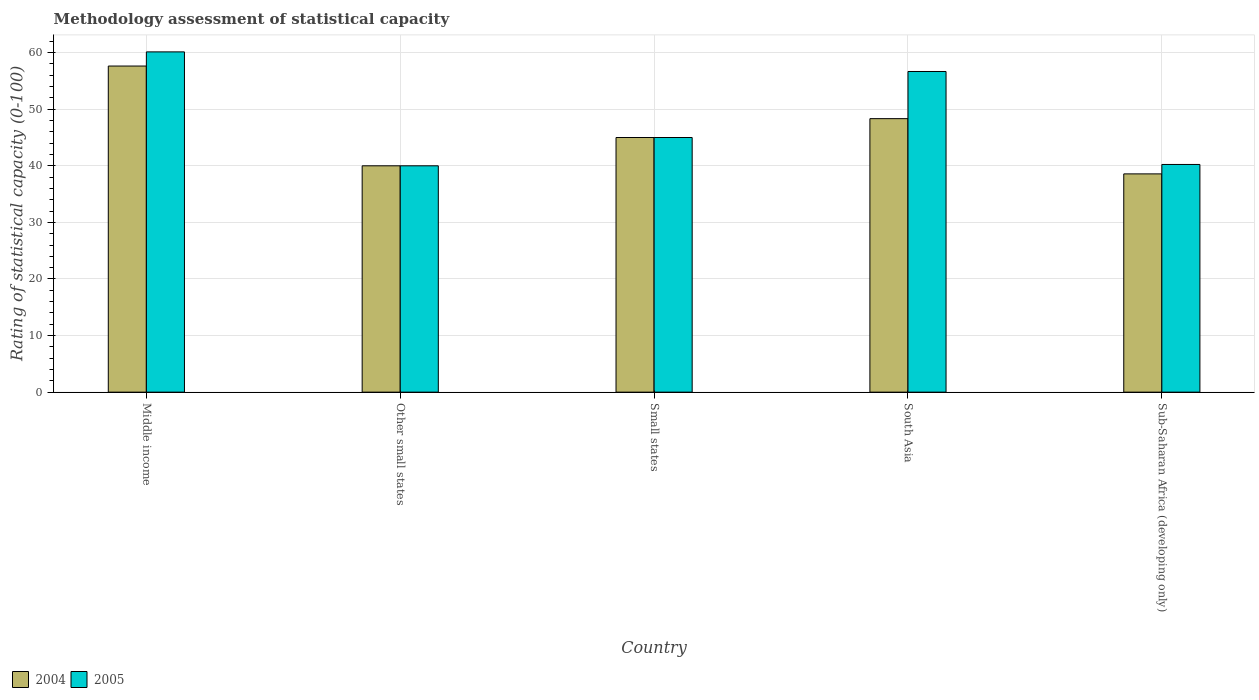How many different coloured bars are there?
Offer a terse response. 2. How many groups of bars are there?
Give a very brief answer. 5. Are the number of bars per tick equal to the number of legend labels?
Provide a succinct answer. Yes. In how many cases, is the number of bars for a given country not equal to the number of legend labels?
Make the answer very short. 0. What is the rating of statistical capacity in 2005 in South Asia?
Give a very brief answer. 56.67. Across all countries, what is the maximum rating of statistical capacity in 2004?
Offer a terse response. 57.63. Across all countries, what is the minimum rating of statistical capacity in 2005?
Provide a succinct answer. 40. In which country was the rating of statistical capacity in 2004 minimum?
Keep it short and to the point. Sub-Saharan Africa (developing only). What is the total rating of statistical capacity in 2005 in the graph?
Your answer should be compact. 242.04. What is the difference between the rating of statistical capacity in 2005 in Middle income and that in Sub-Saharan Africa (developing only)?
Provide a short and direct response. 19.89. What is the difference between the rating of statistical capacity in 2004 in Other small states and the rating of statistical capacity in 2005 in Sub-Saharan Africa (developing only)?
Keep it short and to the point. -0.24. What is the average rating of statistical capacity in 2005 per country?
Ensure brevity in your answer.  48.41. What is the difference between the rating of statistical capacity of/in 2005 and rating of statistical capacity of/in 2004 in South Asia?
Ensure brevity in your answer.  8.33. In how many countries, is the rating of statistical capacity in 2004 greater than 32?
Your answer should be compact. 5. What is the ratio of the rating of statistical capacity in 2005 in Other small states to that in South Asia?
Ensure brevity in your answer.  0.71. What is the difference between the highest and the second highest rating of statistical capacity in 2005?
Give a very brief answer. -3.46. What is the difference between the highest and the lowest rating of statistical capacity in 2004?
Your answer should be compact. 19.06. What does the 1st bar from the left in Small states represents?
Give a very brief answer. 2004. How many bars are there?
Keep it short and to the point. 10. What is the difference between two consecutive major ticks on the Y-axis?
Give a very brief answer. 10. Does the graph contain any zero values?
Offer a terse response. No. Where does the legend appear in the graph?
Your answer should be compact. Bottom left. How many legend labels are there?
Give a very brief answer. 2. What is the title of the graph?
Ensure brevity in your answer.  Methodology assessment of statistical capacity. What is the label or title of the X-axis?
Offer a very short reply. Country. What is the label or title of the Y-axis?
Make the answer very short. Rating of statistical capacity (0-100). What is the Rating of statistical capacity (0-100) of 2004 in Middle income?
Your answer should be very brief. 57.63. What is the Rating of statistical capacity (0-100) of 2005 in Middle income?
Provide a succinct answer. 60.13. What is the Rating of statistical capacity (0-100) of 2004 in Other small states?
Ensure brevity in your answer.  40. What is the Rating of statistical capacity (0-100) in 2005 in Other small states?
Your answer should be very brief. 40. What is the Rating of statistical capacity (0-100) in 2004 in Small states?
Provide a succinct answer. 45. What is the Rating of statistical capacity (0-100) of 2004 in South Asia?
Make the answer very short. 48.33. What is the Rating of statistical capacity (0-100) of 2005 in South Asia?
Your answer should be compact. 56.67. What is the Rating of statistical capacity (0-100) of 2004 in Sub-Saharan Africa (developing only)?
Keep it short and to the point. 38.57. What is the Rating of statistical capacity (0-100) of 2005 in Sub-Saharan Africa (developing only)?
Give a very brief answer. 40.24. Across all countries, what is the maximum Rating of statistical capacity (0-100) in 2004?
Make the answer very short. 57.63. Across all countries, what is the maximum Rating of statistical capacity (0-100) in 2005?
Offer a very short reply. 60.13. Across all countries, what is the minimum Rating of statistical capacity (0-100) in 2004?
Your answer should be compact. 38.57. Across all countries, what is the minimum Rating of statistical capacity (0-100) in 2005?
Provide a short and direct response. 40. What is the total Rating of statistical capacity (0-100) in 2004 in the graph?
Provide a succinct answer. 229.54. What is the total Rating of statistical capacity (0-100) of 2005 in the graph?
Give a very brief answer. 242.04. What is the difference between the Rating of statistical capacity (0-100) of 2004 in Middle income and that in Other small states?
Your answer should be compact. 17.63. What is the difference between the Rating of statistical capacity (0-100) of 2005 in Middle income and that in Other small states?
Your answer should be compact. 20.13. What is the difference between the Rating of statistical capacity (0-100) in 2004 in Middle income and that in Small states?
Provide a short and direct response. 12.63. What is the difference between the Rating of statistical capacity (0-100) in 2005 in Middle income and that in Small states?
Your response must be concise. 15.13. What is the difference between the Rating of statistical capacity (0-100) of 2004 in Middle income and that in South Asia?
Give a very brief answer. 9.3. What is the difference between the Rating of statistical capacity (0-100) in 2005 in Middle income and that in South Asia?
Your answer should be compact. 3.46. What is the difference between the Rating of statistical capacity (0-100) of 2004 in Middle income and that in Sub-Saharan Africa (developing only)?
Offer a very short reply. 19.06. What is the difference between the Rating of statistical capacity (0-100) in 2005 in Middle income and that in Sub-Saharan Africa (developing only)?
Offer a very short reply. 19.89. What is the difference between the Rating of statistical capacity (0-100) in 2004 in Other small states and that in South Asia?
Keep it short and to the point. -8.33. What is the difference between the Rating of statistical capacity (0-100) in 2005 in Other small states and that in South Asia?
Provide a succinct answer. -16.67. What is the difference between the Rating of statistical capacity (0-100) in 2004 in Other small states and that in Sub-Saharan Africa (developing only)?
Offer a very short reply. 1.43. What is the difference between the Rating of statistical capacity (0-100) in 2005 in Other small states and that in Sub-Saharan Africa (developing only)?
Your answer should be very brief. -0.24. What is the difference between the Rating of statistical capacity (0-100) of 2004 in Small states and that in South Asia?
Keep it short and to the point. -3.33. What is the difference between the Rating of statistical capacity (0-100) of 2005 in Small states and that in South Asia?
Provide a succinct answer. -11.67. What is the difference between the Rating of statistical capacity (0-100) in 2004 in Small states and that in Sub-Saharan Africa (developing only)?
Keep it short and to the point. 6.43. What is the difference between the Rating of statistical capacity (0-100) in 2005 in Small states and that in Sub-Saharan Africa (developing only)?
Offer a terse response. 4.76. What is the difference between the Rating of statistical capacity (0-100) of 2004 in South Asia and that in Sub-Saharan Africa (developing only)?
Your answer should be very brief. 9.76. What is the difference between the Rating of statistical capacity (0-100) of 2005 in South Asia and that in Sub-Saharan Africa (developing only)?
Give a very brief answer. 16.43. What is the difference between the Rating of statistical capacity (0-100) of 2004 in Middle income and the Rating of statistical capacity (0-100) of 2005 in Other small states?
Your answer should be compact. 17.63. What is the difference between the Rating of statistical capacity (0-100) in 2004 in Middle income and the Rating of statistical capacity (0-100) in 2005 in Small states?
Your answer should be compact. 12.63. What is the difference between the Rating of statistical capacity (0-100) of 2004 in Middle income and the Rating of statistical capacity (0-100) of 2005 in South Asia?
Make the answer very short. 0.96. What is the difference between the Rating of statistical capacity (0-100) of 2004 in Middle income and the Rating of statistical capacity (0-100) of 2005 in Sub-Saharan Africa (developing only)?
Your response must be concise. 17.39. What is the difference between the Rating of statistical capacity (0-100) in 2004 in Other small states and the Rating of statistical capacity (0-100) in 2005 in Small states?
Provide a short and direct response. -5. What is the difference between the Rating of statistical capacity (0-100) of 2004 in Other small states and the Rating of statistical capacity (0-100) of 2005 in South Asia?
Provide a short and direct response. -16.67. What is the difference between the Rating of statistical capacity (0-100) in 2004 in Other small states and the Rating of statistical capacity (0-100) in 2005 in Sub-Saharan Africa (developing only)?
Make the answer very short. -0.24. What is the difference between the Rating of statistical capacity (0-100) of 2004 in Small states and the Rating of statistical capacity (0-100) of 2005 in South Asia?
Provide a short and direct response. -11.67. What is the difference between the Rating of statistical capacity (0-100) of 2004 in Small states and the Rating of statistical capacity (0-100) of 2005 in Sub-Saharan Africa (developing only)?
Keep it short and to the point. 4.76. What is the difference between the Rating of statistical capacity (0-100) of 2004 in South Asia and the Rating of statistical capacity (0-100) of 2005 in Sub-Saharan Africa (developing only)?
Your answer should be compact. 8.1. What is the average Rating of statistical capacity (0-100) of 2004 per country?
Give a very brief answer. 45.91. What is the average Rating of statistical capacity (0-100) of 2005 per country?
Offer a terse response. 48.41. What is the difference between the Rating of statistical capacity (0-100) in 2004 and Rating of statistical capacity (0-100) in 2005 in Middle income?
Your answer should be compact. -2.5. What is the difference between the Rating of statistical capacity (0-100) of 2004 and Rating of statistical capacity (0-100) of 2005 in Small states?
Offer a terse response. 0. What is the difference between the Rating of statistical capacity (0-100) of 2004 and Rating of statistical capacity (0-100) of 2005 in South Asia?
Offer a very short reply. -8.33. What is the difference between the Rating of statistical capacity (0-100) of 2004 and Rating of statistical capacity (0-100) of 2005 in Sub-Saharan Africa (developing only)?
Your answer should be compact. -1.67. What is the ratio of the Rating of statistical capacity (0-100) of 2004 in Middle income to that in Other small states?
Your answer should be very brief. 1.44. What is the ratio of the Rating of statistical capacity (0-100) in 2005 in Middle income to that in Other small states?
Your answer should be compact. 1.5. What is the ratio of the Rating of statistical capacity (0-100) of 2004 in Middle income to that in Small states?
Your response must be concise. 1.28. What is the ratio of the Rating of statistical capacity (0-100) of 2005 in Middle income to that in Small states?
Offer a very short reply. 1.34. What is the ratio of the Rating of statistical capacity (0-100) of 2004 in Middle income to that in South Asia?
Your answer should be compact. 1.19. What is the ratio of the Rating of statistical capacity (0-100) in 2005 in Middle income to that in South Asia?
Make the answer very short. 1.06. What is the ratio of the Rating of statistical capacity (0-100) of 2004 in Middle income to that in Sub-Saharan Africa (developing only)?
Give a very brief answer. 1.49. What is the ratio of the Rating of statistical capacity (0-100) of 2005 in Middle income to that in Sub-Saharan Africa (developing only)?
Make the answer very short. 1.49. What is the ratio of the Rating of statistical capacity (0-100) of 2004 in Other small states to that in Small states?
Provide a short and direct response. 0.89. What is the ratio of the Rating of statistical capacity (0-100) of 2004 in Other small states to that in South Asia?
Your answer should be compact. 0.83. What is the ratio of the Rating of statistical capacity (0-100) in 2005 in Other small states to that in South Asia?
Keep it short and to the point. 0.71. What is the ratio of the Rating of statistical capacity (0-100) in 2004 in Other small states to that in Sub-Saharan Africa (developing only)?
Offer a very short reply. 1.04. What is the ratio of the Rating of statistical capacity (0-100) of 2005 in Small states to that in South Asia?
Offer a terse response. 0.79. What is the ratio of the Rating of statistical capacity (0-100) in 2004 in Small states to that in Sub-Saharan Africa (developing only)?
Ensure brevity in your answer.  1.17. What is the ratio of the Rating of statistical capacity (0-100) of 2005 in Small states to that in Sub-Saharan Africa (developing only)?
Your answer should be very brief. 1.12. What is the ratio of the Rating of statistical capacity (0-100) of 2004 in South Asia to that in Sub-Saharan Africa (developing only)?
Give a very brief answer. 1.25. What is the ratio of the Rating of statistical capacity (0-100) in 2005 in South Asia to that in Sub-Saharan Africa (developing only)?
Ensure brevity in your answer.  1.41. What is the difference between the highest and the second highest Rating of statistical capacity (0-100) of 2004?
Offer a very short reply. 9.3. What is the difference between the highest and the second highest Rating of statistical capacity (0-100) of 2005?
Keep it short and to the point. 3.46. What is the difference between the highest and the lowest Rating of statistical capacity (0-100) in 2004?
Offer a very short reply. 19.06. What is the difference between the highest and the lowest Rating of statistical capacity (0-100) in 2005?
Make the answer very short. 20.13. 